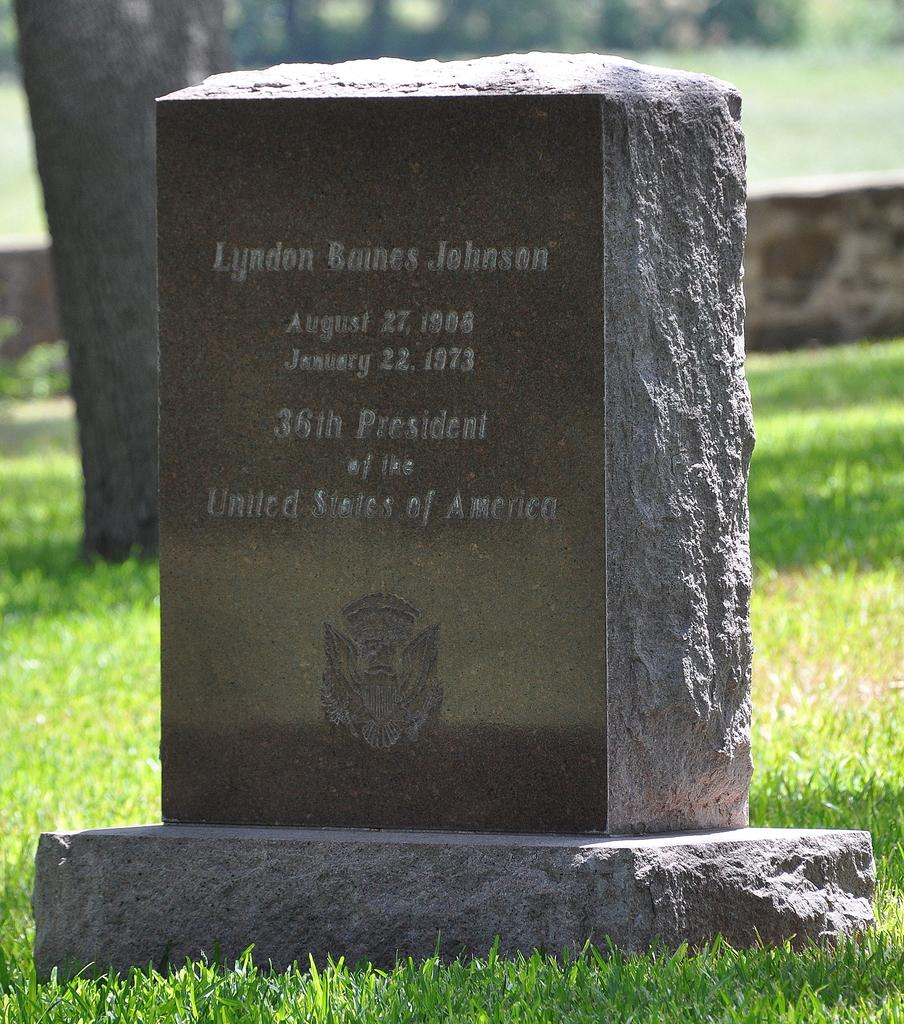What is the main subject of the image? There is a memorial statue in the image. What can be found on the statue? There is text on the statue. What type of natural environment is visible in the image? There is grass visible in the image. How would you describe the background of the image? The background of the image is blurred. Can you tell me how many people are gathered around the cake in the image? There is no cake present in the image, and therefore no crowd gathered around it. What type of bun is sitting on the memorial statue in the image? There is no bun present on the memorial statue in the image. 